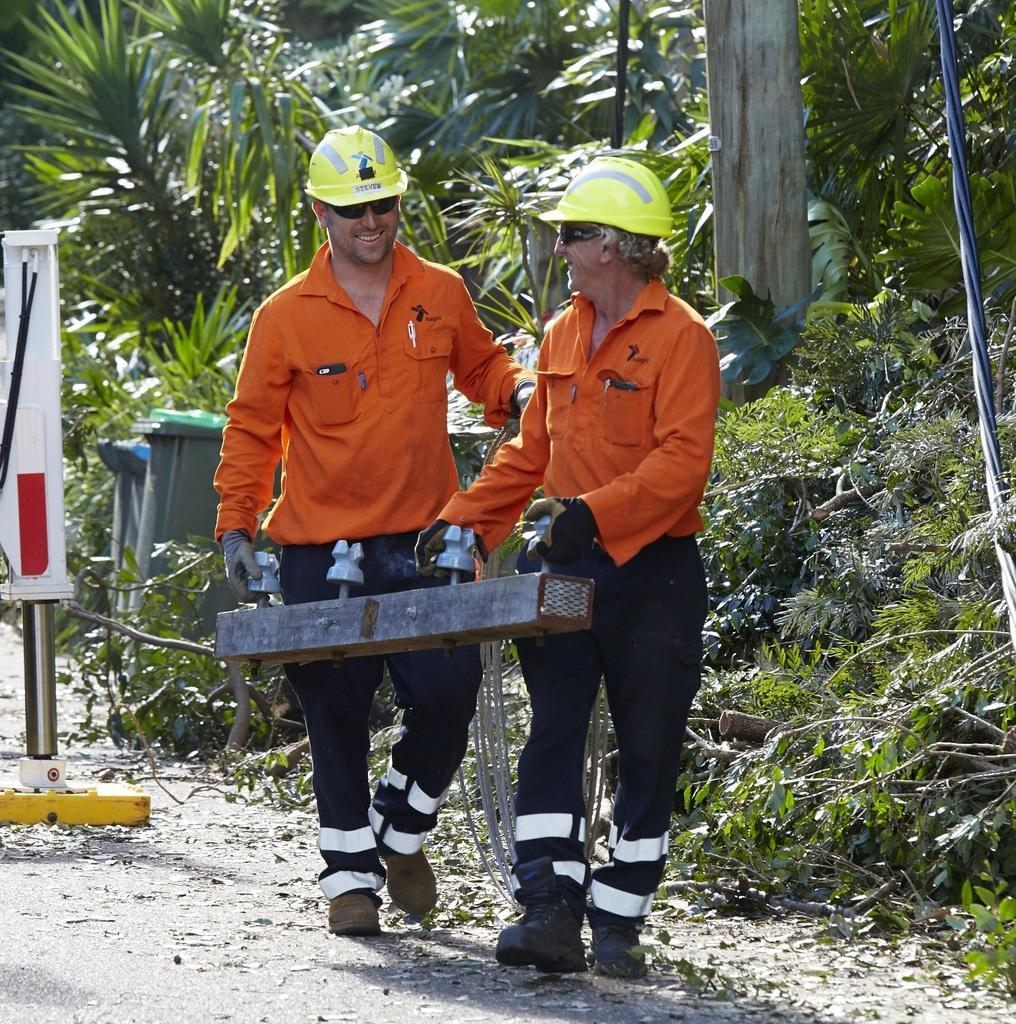Can you describe this image briefly? In this image at front there are two persons holding an object. At the back side there are trees, dustbins and there is some object at the center of the image. 